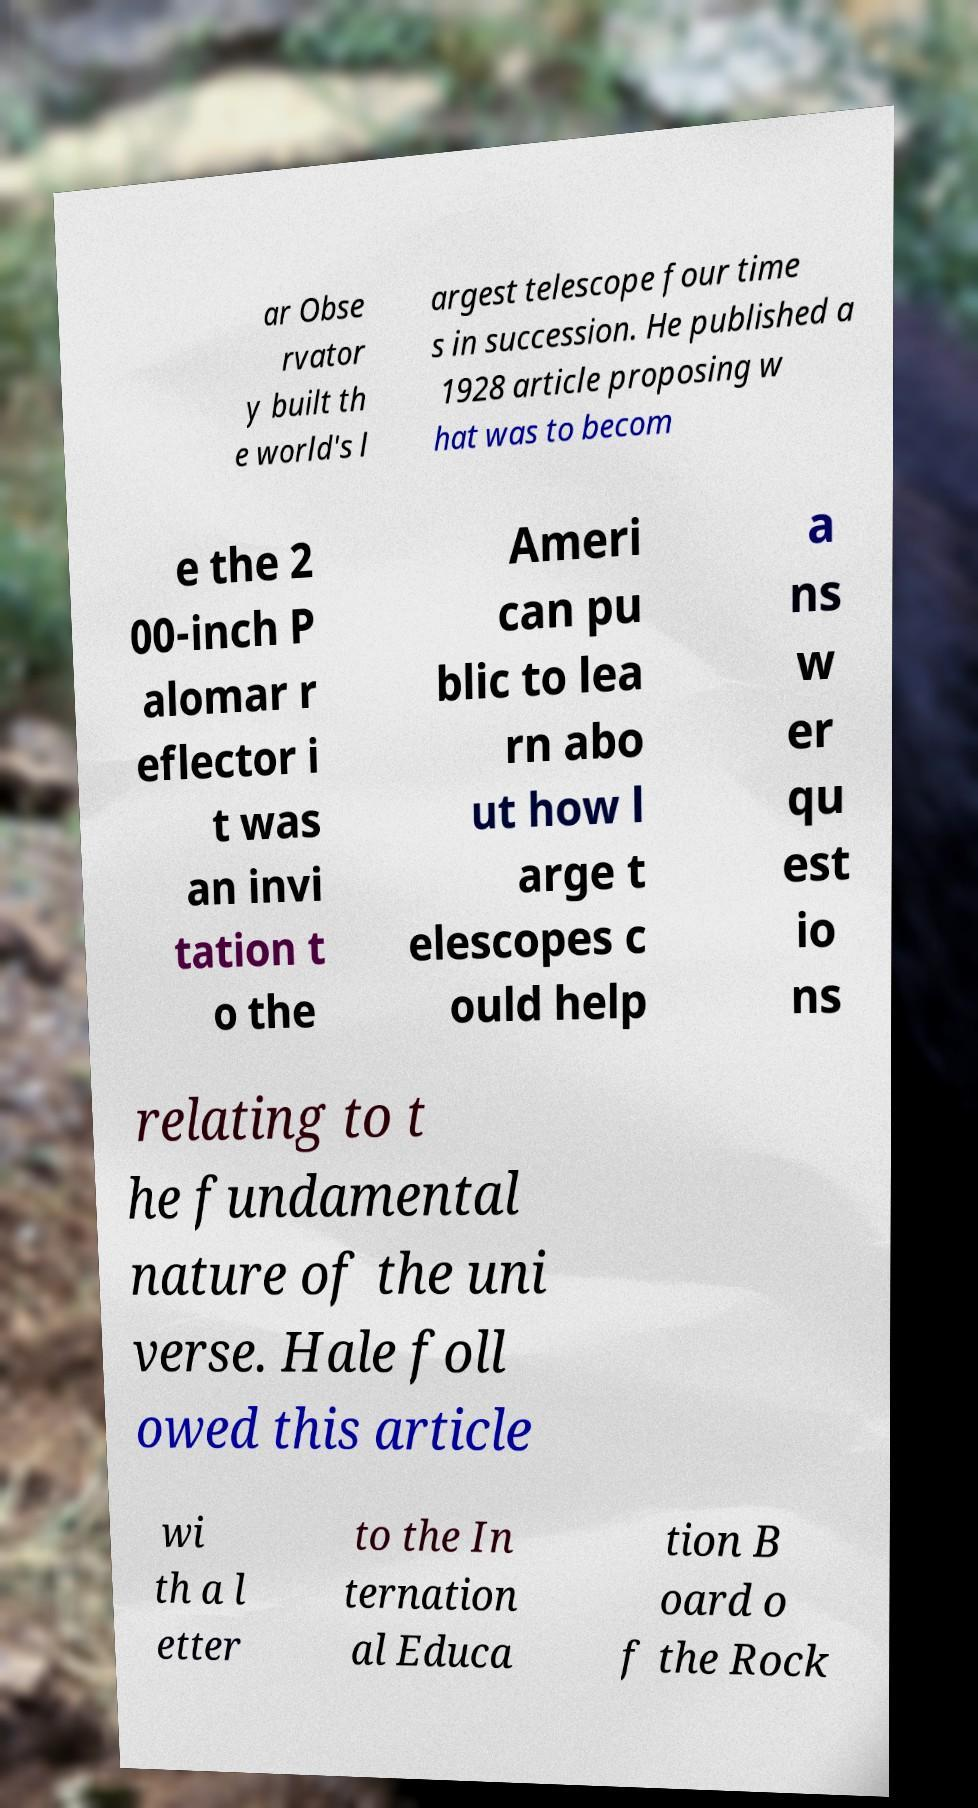For documentation purposes, I need the text within this image transcribed. Could you provide that? ar Obse rvator y built th e world's l argest telescope four time s in succession. He published a 1928 article proposing w hat was to becom e the 2 00-inch P alomar r eflector i t was an invi tation t o the Ameri can pu blic to lea rn abo ut how l arge t elescopes c ould help a ns w er qu est io ns relating to t he fundamental nature of the uni verse. Hale foll owed this article wi th a l etter to the In ternation al Educa tion B oard o f the Rock 